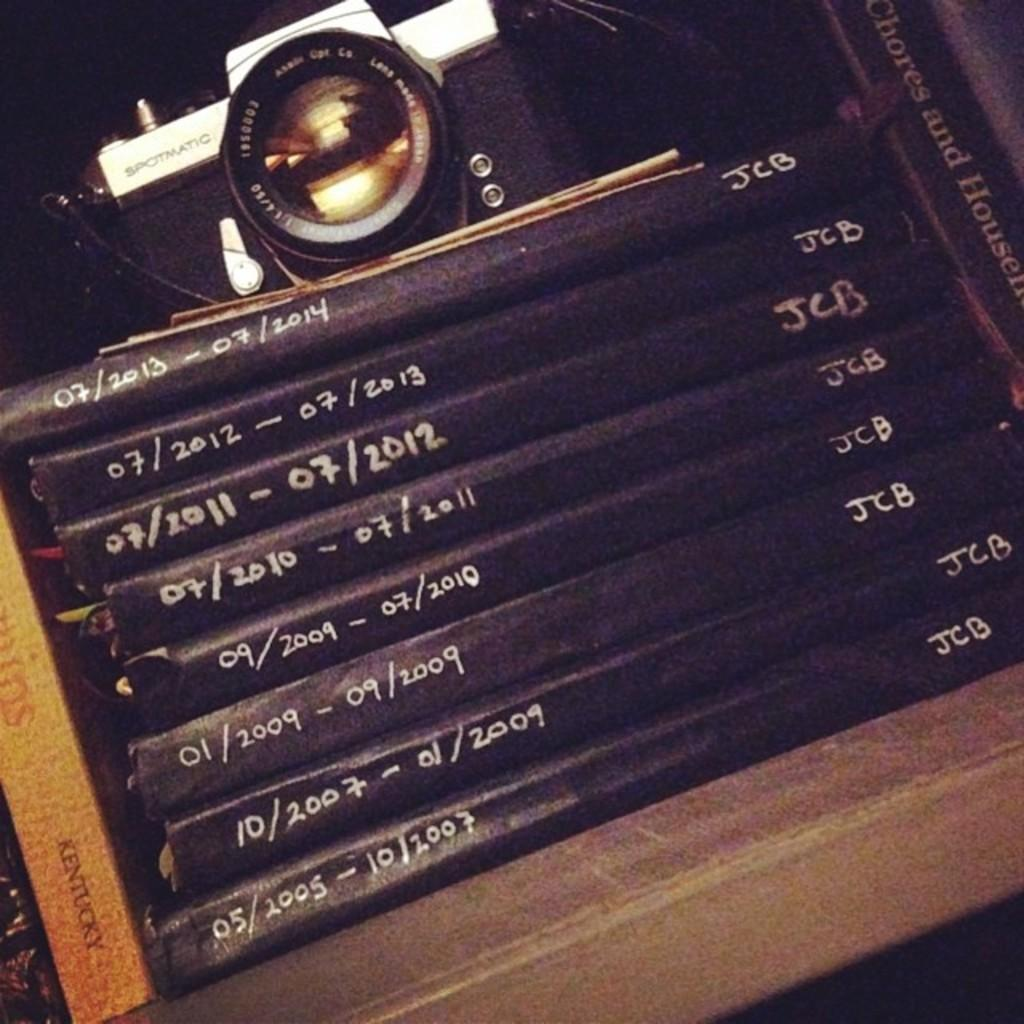<image>
Share a concise interpretation of the image provided. A bunch of JCB's notebooks are labeled with date ranges on the spines. 